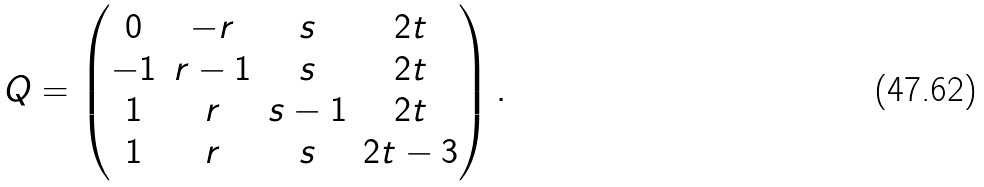Convert formula to latex. <formula><loc_0><loc_0><loc_500><loc_500>Q = \begin{pmatrix} 0 & - r & s & 2 t \\ - 1 & r - 1 & s & 2 t \\ 1 & r & s - 1 & 2 t \\ 1 & r & s & 2 t - 3 \end{pmatrix} .</formula> 